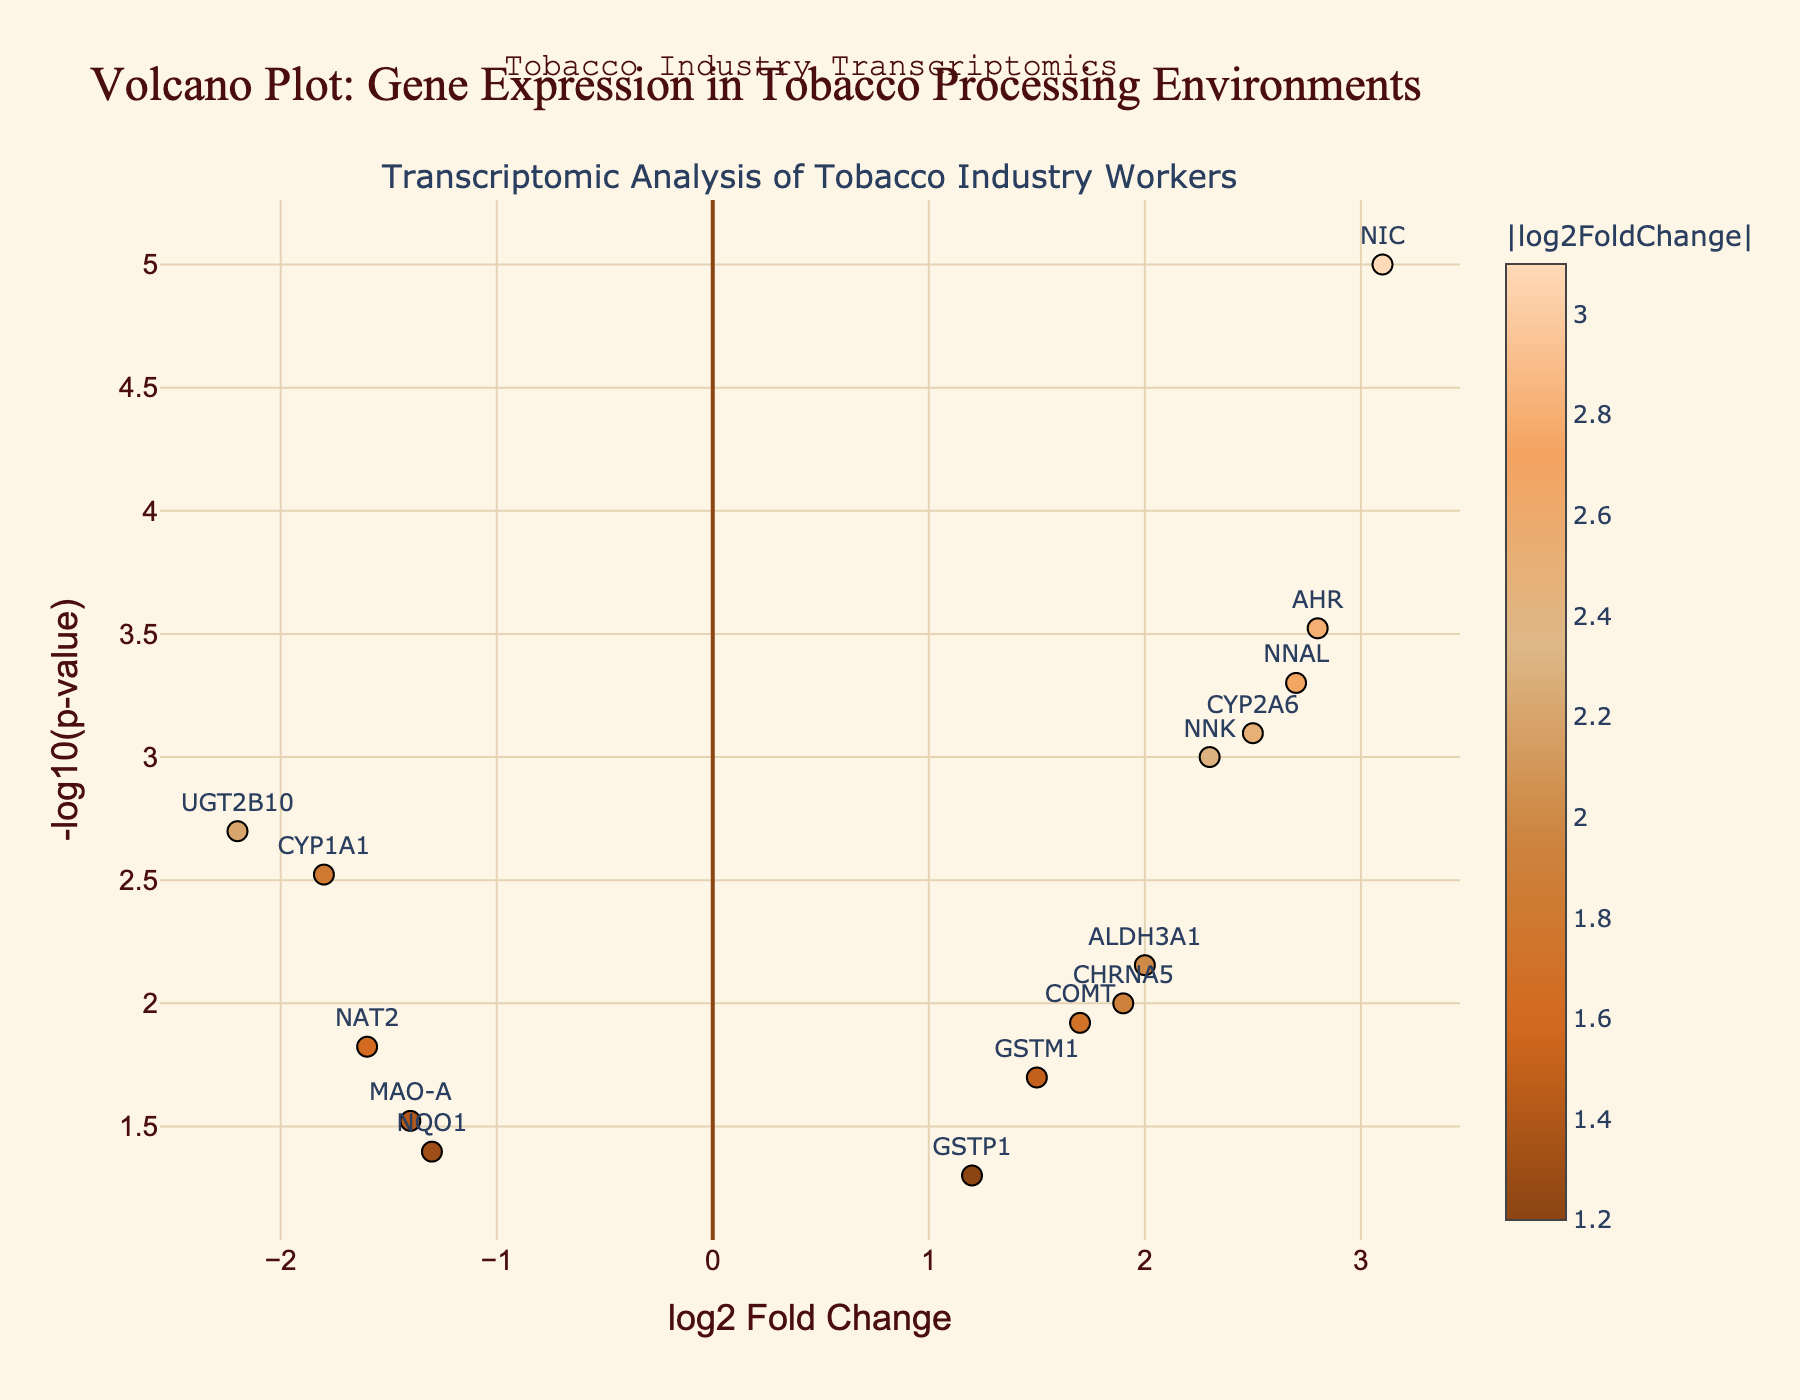How many genes are labeled on the plot? Count the number of genes displayed with labels directly on the plotted data points.
Answer: 15 What is the title of the plot? Look at the main title displayed at the top of the figure.
Answer: Volcano Plot: Gene Expression in Tobacco Processing Environments What is the axis label for the x-axis? Check the label along the horizontal axis at the bottom of the plot.
Answer: log2 Fold Change Which gene has the highest log2 Fold Change value? Compare the log2 Fold Change values of all genes and identify the one with the maximum value.
Answer: NIC What is the log2 Fold Change and p-value of the gene CYP1A1? Read the respective data point value for log2 Fold Change and p-value displayed on the plot for the gene labeled CYP1A1.
Answer: -1.8 and 0.003 Which gene has the smallest p-value, and what is that value? Identify the gene with the smallest p-value by referring to the y-axis values, as the smallest p-value will have the largest -log10(p-value).
Answer: NIC, 0.00001 Which gene has the most significant downregulation? Look at the gene with the most negative log2 Fold Change value (farthest to the left).
Answer: UGT2B10 What is the -log10(p-value) for the gene AHR? Locate the gene AHR on the plot and read its -log10(p-value) from the y-axis scale or hover information.
Answer: AHR has a -log10(p-value) of 3.52 (using -log10(0.0003)) How many genes have a -log10(p-value) greater than 3? Count the number of genes that have their data points above the value of 3 on the y-axis.
Answer: 5 